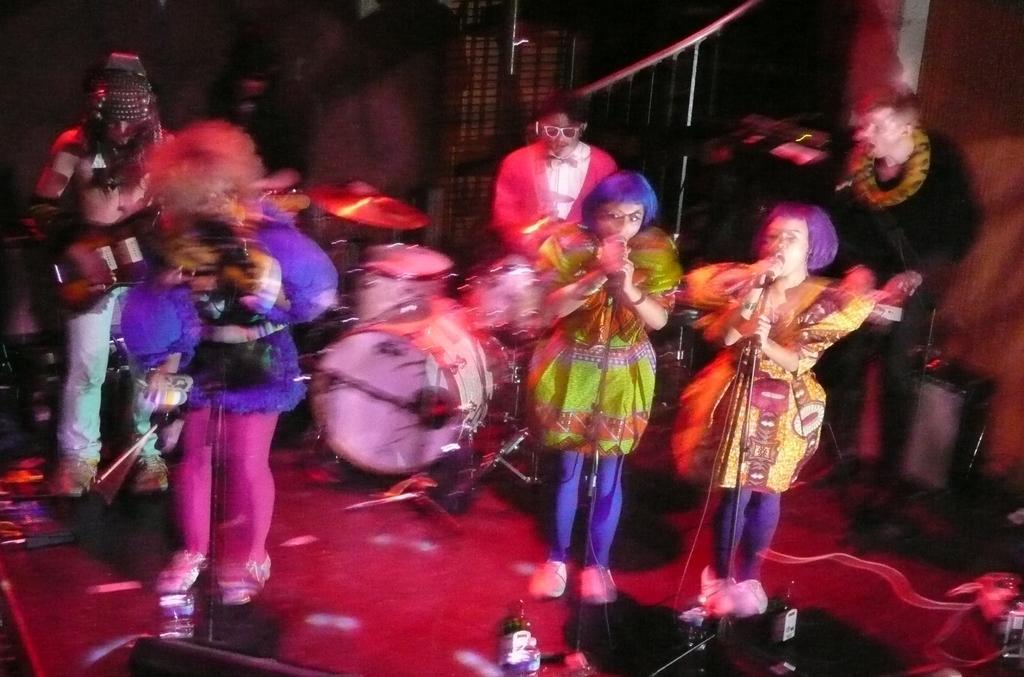Could you give a brief overview of what you see in this image? This picture is clicked in the musical concert. In the middle, we see two women are standing and they are holding the microphones in their hands. They are singing the songs on the microphone. Behind them, we see a man is standing and he is playing a musical instrument. Beside him, we see a man is playing the drums. On the left side, we see a woman is standing and she is holding a microphone in her hand. Behind her, we see a man is standing and he is holding a guitar in his hands. At the bottom, we see the speaker boxes. In the background, we see a wall and the windows. 